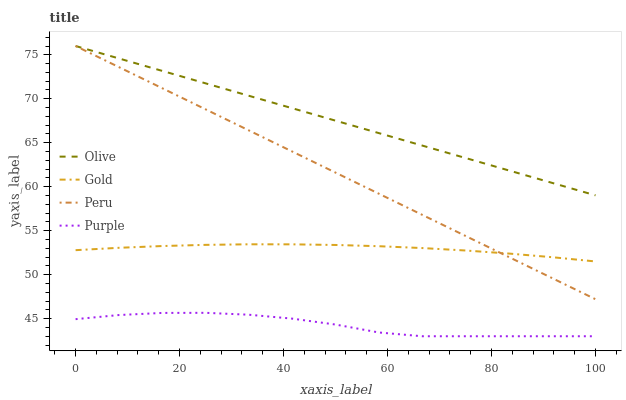Does Purple have the minimum area under the curve?
Answer yes or no. Yes. Does Olive have the maximum area under the curve?
Answer yes or no. Yes. Does Peru have the minimum area under the curve?
Answer yes or no. No. Does Peru have the maximum area under the curve?
Answer yes or no. No. Is Peru the smoothest?
Answer yes or no. Yes. Is Purple the roughest?
Answer yes or no. Yes. Is Purple the smoothest?
Answer yes or no. No. Is Peru the roughest?
Answer yes or no. No. Does Purple have the lowest value?
Answer yes or no. Yes. Does Peru have the lowest value?
Answer yes or no. No. Does Peru have the highest value?
Answer yes or no. Yes. Does Purple have the highest value?
Answer yes or no. No. Is Purple less than Olive?
Answer yes or no. Yes. Is Gold greater than Purple?
Answer yes or no. Yes. Does Olive intersect Peru?
Answer yes or no. Yes. Is Olive less than Peru?
Answer yes or no. No. Is Olive greater than Peru?
Answer yes or no. No. Does Purple intersect Olive?
Answer yes or no. No. 